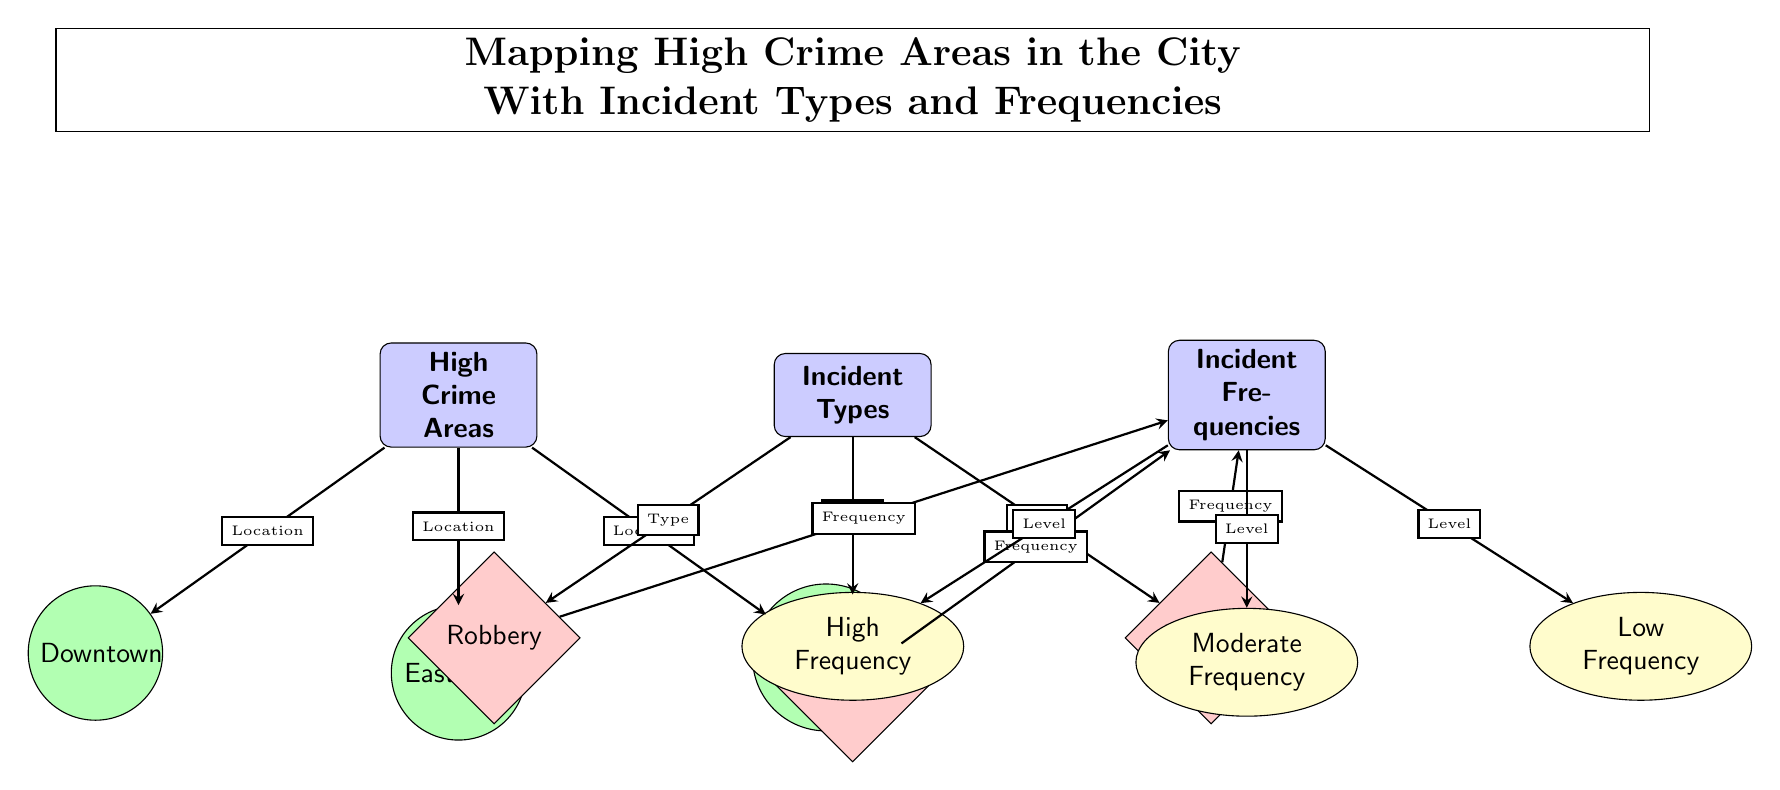What are the three high crime areas depicted in the diagram? The diagram lists three high crime areas: Downtown, East Side, and West End, located below the "High Crime Areas" category. Each area is represented as a location node connected to the high crime areas node.
Answer: Downtown, East Side, West End Which incident type is associated with high frequency? The incident types listed are Robbery, Assault, and Burglary. Each type is connected to the frequency category, but there is no specific mention of which one is high directly in this diagram; therefore, we focus on identifying which incident type appears in the high frequency node and reason from the incident connection.
Answer: Robbery How many incident types are shown in the diagram? The diagram displays three distinct incident types: Robbery, Assault, and Burglary. These incidents are listed under the "Incident Types" category, each represented as an incident node.
Answer: 3 What connects the "Incident Types" to "Incident Frequencies"? The relationship depicted in the diagram illustrates that each incident type (Robbery, Assault, Burglary) connects to the "Incident Frequencies" category. Each connection shows a directed flow towards that category indicating how incident types relate to their respective frequencies.
Answer: Type Which incident frequency category has the most connections? The "Incident Frequencies" has three distinct connections stemming from the incident types: High Frequency, Moderate Frequency, and Low Frequency. Since each incident type is linked separately to this category, the frequency category itself would maintain equality in connection count amongst them, but we look into how many types connect to high frequency most prominently.
Answer: High Frequency What do the edges in the diagram signify? The edges in the diagram indicate the relationships or connections between the categories and nodes. They show the flow of information, such as how high crime areas relate to specific locations, incident types, and the corresponding frequencies of these incidents. The directional signals also imply a logical progression from types to frequencies.
Answer: Relationships What level of frequency is associated with Assault in the diagram? In the current set-up of the diagram, there is no specific indication of the frequency level assigned to Assault. Each incident's frequency node (High, Moderate, Low) depends on external data not contained within just this visual mapping. However, one can speculate based on common occurrences.
Answer: Not specified How is the data about crime categorized in the diagram? The diagram categorizes crime data primarily into three sections: High Crime Areas, Incident Types, and Incident Frequencies. Each section not only identifies distinct elements of crime but also how they relate through connections among locations, types, and frequency levels. This indicates an organized framework to analyze crime-related data visually.
Answer: Three categories 